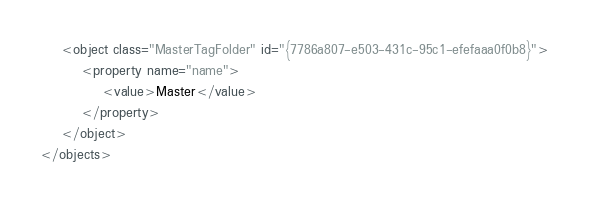<code> <loc_0><loc_0><loc_500><loc_500><_XML_>	<object class="MasterTagFolder" id="{7786a807-e503-431c-95c1-efefaaa0f0b8}">
		<property name="name">
			<value>Master</value>
		</property>
	</object>
</objects>
</code> 